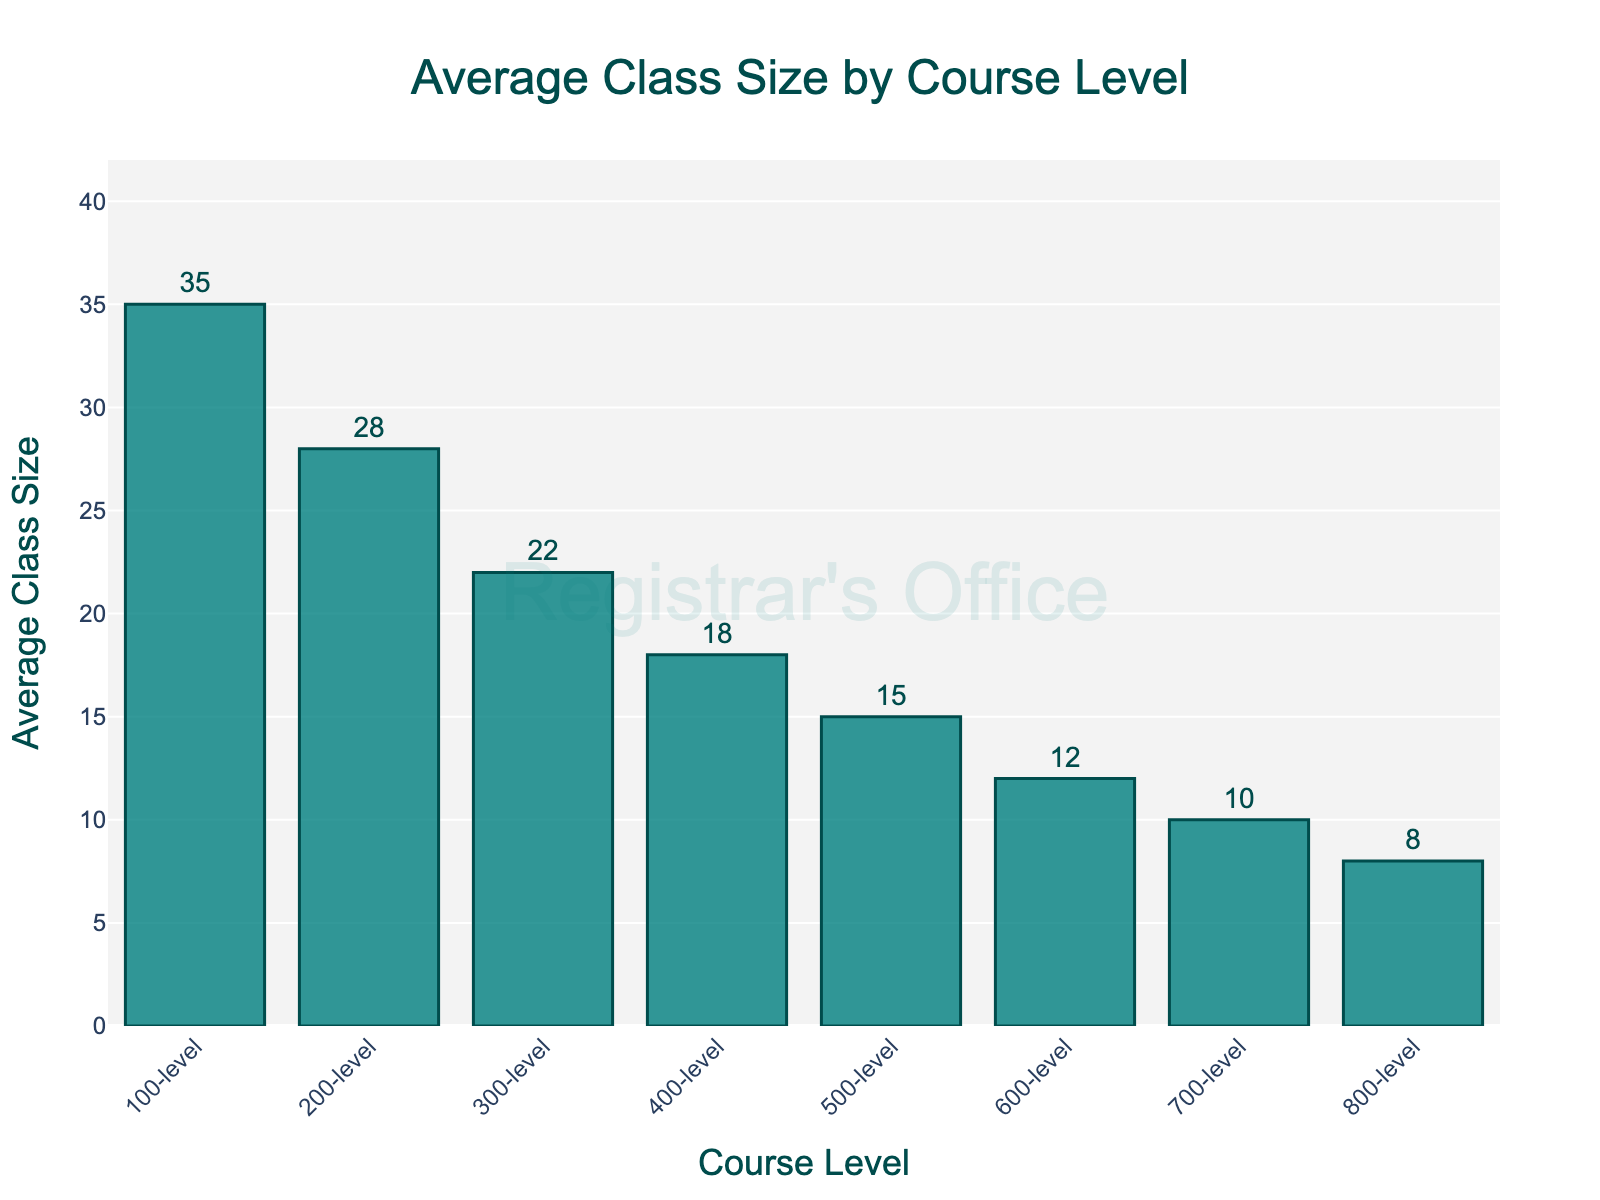What's the average class size for 300-level courses? The figure shows the average class sizes for different course levels. For 300-level courses, the bar is labeled 22 and has a text annotation showing 22.
Answer: 22 How do the average class sizes for 100-level and 400-level courses compare? Look at the bar heights and text annotations for 100-level and 400-level courses. The 100-level has an average class size of 35, and the 400-level has 18. Comparing these values shows that the 100-level courses have larger class sizes than 400-level courses.
Answer: 100-level > 400-level What is the overall trend in average class size as the course level increases from 100-level to 800-level? Observe the height of the bars from 100-level to 800-level; the heights of the bars decrease progressively. This indicates that the average class size decreases as the course level increases.
Answer: Decreases What is the difference in average class size between 200-level and 600-level courses? The average class size for 200-level courses is 28, and for 600-level courses, it is 12. Subtract 12 from 28 to find the difference.
Answer: 16 Which course level has the smallest average class size, and what is this size? The smallest bar corresponds to the 800-level courses, which has a text annotation showing 8.
Answer: 800-level, 8 By what percentage does the average class size decrease from 500-level to 700-level? The average class size for 500-level courses is 15, and for 700-level courses, it's 10. Calculate the percentage decrease: ((15 - 10) / 15) * 100.
Answer: 33.33% Given the average class sizes, what is the median value among the different course levels? List the class sizes: 35, 28, 22, 18, 15, 12, 10, 8. The median is the average of the fourth and fifth values, 18 and 15. Calculate (18 + 15) / 2.
Answer: 16.5 